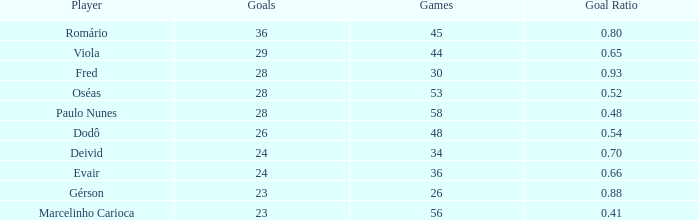Could you help me parse every detail presented in this table? {'header': ['Player', 'Goals', 'Games', 'Goal Ratio'], 'rows': [['Romário', '36', '45', '0.80'], ['Viola', '29', '44', '0.65'], ['Fred', '28', '30', '0.93'], ['Oséas', '28', '53', '0.52'], ['Paulo Nunes', '28', '58', '0.48'], ['Dodô', '26', '48', '0.54'], ['Deivid', '24', '34', '0.70'], ['Evair', '24', '36', '0.66'], ['Gérson', '23', '26', '0.88'], ['Marcelinho Carioca', '23', '56', '0.41']]} What is the largest value for goals in rank over 3 with goal ration of 0.54? 26.0. 